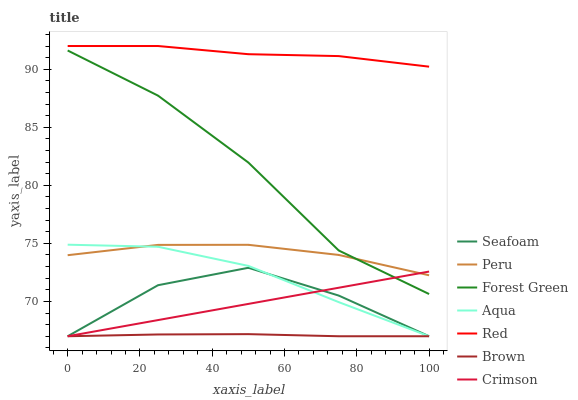Does Brown have the minimum area under the curve?
Answer yes or no. Yes. Does Red have the maximum area under the curve?
Answer yes or no. Yes. Does Aqua have the minimum area under the curve?
Answer yes or no. No. Does Aqua have the maximum area under the curve?
Answer yes or no. No. Is Crimson the smoothest?
Answer yes or no. Yes. Is Seafoam the roughest?
Answer yes or no. Yes. Is Aqua the smoothest?
Answer yes or no. No. Is Aqua the roughest?
Answer yes or no. No. Does Forest Green have the lowest value?
Answer yes or no. No. Does Aqua have the highest value?
Answer yes or no. No. Is Seafoam less than Red?
Answer yes or no. Yes. Is Forest Green greater than Seafoam?
Answer yes or no. Yes. Does Seafoam intersect Red?
Answer yes or no. No. 